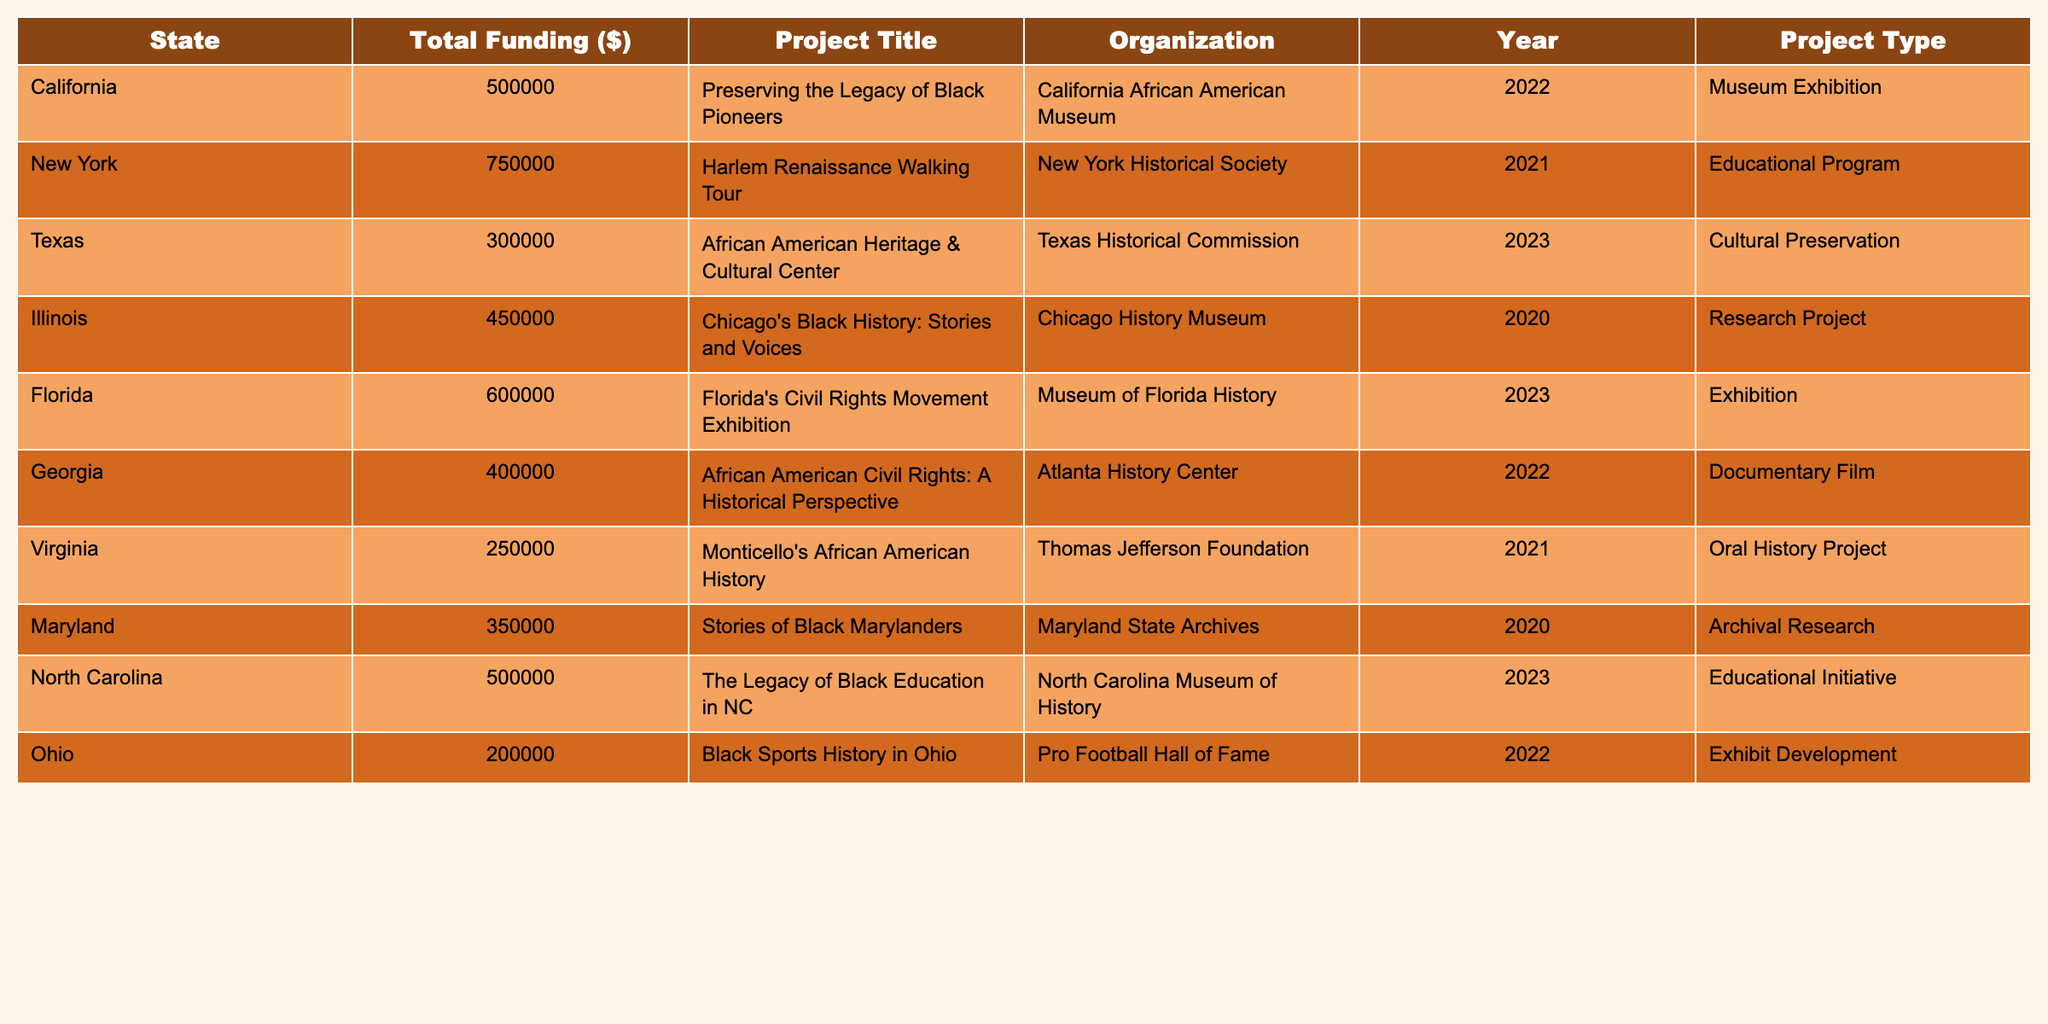What was the total funding allocated to projects in California? The table shows that California has a total funding of $500,000 allocated to the project titled "Preserving the Legacy of Black Pioneers."
Answer: $500,000 Which project received the highest amount of funding? Looking through the 'Total Funding' column, the project "Harlem Renaissance Walking Tour" in New York received the highest funding of $750,000.
Answer: $750,000 Is there any project funded in 2020? By examining the 'Year' column, it is clear that there are two projects funded in 2020: "Chicago's Black History: Stories and Voices" and "Stories of Black Marylanders."
Answer: Yes What is the average funding amount for projects in 2023? There are two projects listed for 2023: "African American Heritage & Cultural Center" in Texas with $300,000 and "Florida's Civil Rights Movement Exhibition" in Florida with $600,000. The total funding for 2023 is $300,000 + $600,000 = $900,000, and since there are 2 projects, the average funding is $900,000 / 2 = $450,000.
Answer: $450,000 How many projects are located in the state of Georgia? The table indicates there is one project based in Georgia, titled "African American Civil Rights: A Historical Perspective."
Answer: 1 What is the difference in funding between the project in Virginia and the project in Florida? The project in Virginia received $250,000 for "Monticello's African American History," while the project in Florida received $600,000 for "Florida's Civil Rights Movement Exhibition." The difference in funding is $600,000 - $250,000 = $350,000.
Answer: $350,000 Which organization is associated with the project about Black Sports History in Ohio? The entry for "Black Sports History in Ohio" indicates that the associated organization is the Pro Football Hall of Fame.
Answer: Pro Football Hall of Fame Are there any educational programs listed in the table? The table shows that "Harlem Renaissance Walking Tour" and "The Legacy of Black Education in NC" are both classified as educational programs. Thus, there are educational programs listed.
Answer: Yes What state has the lowest funding allocation for its project? By reviewing the total funding amounts, the project in Ohio received the lowest amount of $200,000. Therefore, the state with the lowest funding allocation is Ohio.
Answer: Ohio 